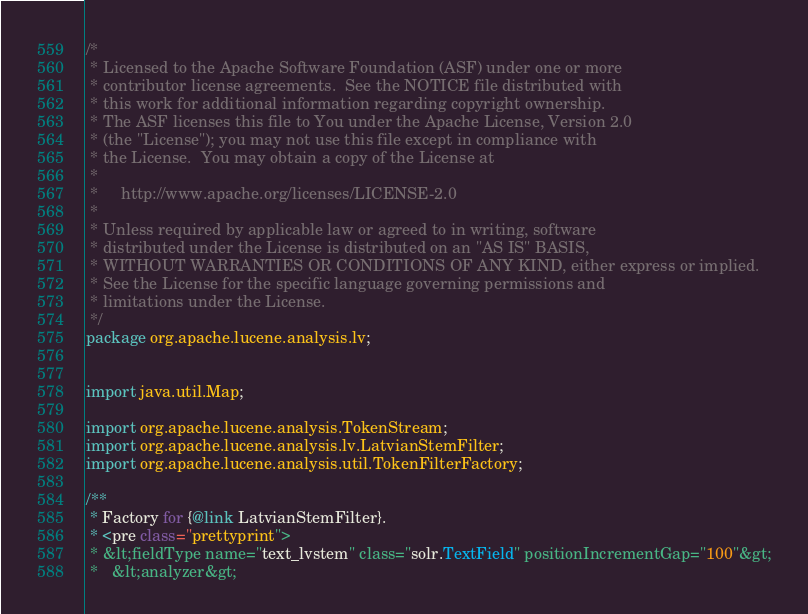Convert code to text. <code><loc_0><loc_0><loc_500><loc_500><_Java_>/*
 * Licensed to the Apache Software Foundation (ASF) under one or more
 * contributor license agreements.  See the NOTICE file distributed with
 * this work for additional information regarding copyright ownership.
 * The ASF licenses this file to You under the Apache License, Version 2.0
 * (the "License"); you may not use this file except in compliance with
 * the License.  You may obtain a copy of the License at
 *
 *     http://www.apache.org/licenses/LICENSE-2.0
 *
 * Unless required by applicable law or agreed to in writing, software
 * distributed under the License is distributed on an "AS IS" BASIS,
 * WITHOUT WARRANTIES OR CONDITIONS OF ANY KIND, either express or implied.
 * See the License for the specific language governing permissions and
 * limitations under the License.
 */
package org.apache.lucene.analysis.lv;


import java.util.Map;

import org.apache.lucene.analysis.TokenStream;
import org.apache.lucene.analysis.lv.LatvianStemFilter;
import org.apache.lucene.analysis.util.TokenFilterFactory;

/** 
 * Factory for {@link LatvianStemFilter}. 
 * <pre class="prettyprint">
 * &lt;fieldType name="text_lvstem" class="solr.TextField" positionIncrementGap="100"&gt;
 *   &lt;analyzer&gt;</code> 